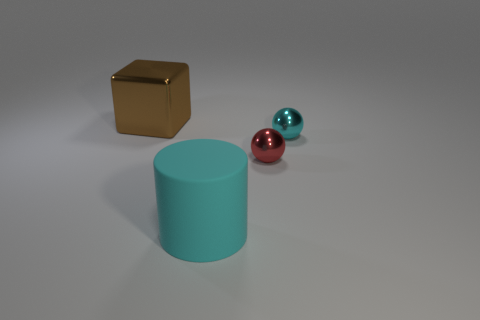What shape is the small object that is the same color as the big rubber thing?
Give a very brief answer. Sphere. There is a big object behind the large cyan matte cylinder; what number of big cylinders are in front of it?
Your answer should be compact. 1. What material is the cylinder?
Your response must be concise. Rubber. There is a brown block; how many big cyan cylinders are left of it?
Provide a short and direct response. 0. Does the big matte cylinder have the same color as the large block?
Provide a succinct answer. No. What number of matte things are the same color as the big matte cylinder?
Provide a succinct answer. 0. Is the number of objects greater than the number of cubes?
Offer a terse response. Yes. There is a shiny thing that is to the right of the brown object and left of the cyan sphere; what size is it?
Provide a succinct answer. Small. Are the big thing behind the matte cylinder and the large object in front of the large brown metal block made of the same material?
Your answer should be very brief. No. There is a thing that is the same size as the red metallic sphere; what shape is it?
Your response must be concise. Sphere. 